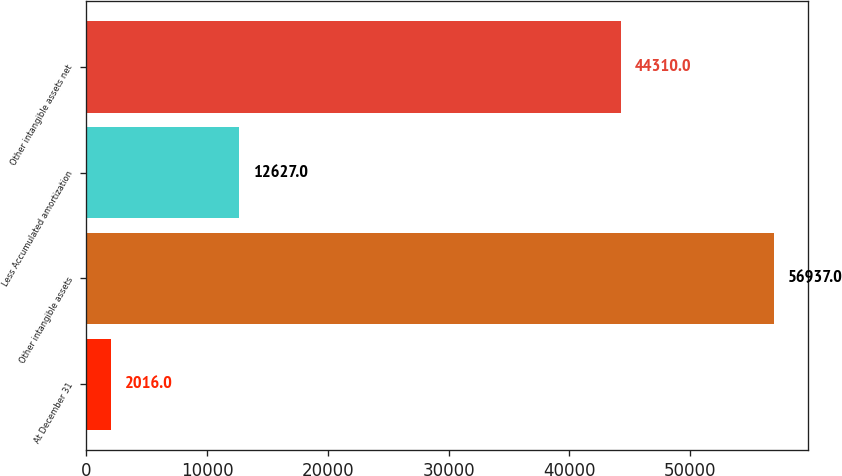Convert chart to OTSL. <chart><loc_0><loc_0><loc_500><loc_500><bar_chart><fcel>At December 31<fcel>Other intangible assets<fcel>Less Accumulated amortization<fcel>Other intangible assets net<nl><fcel>2016<fcel>56937<fcel>12627<fcel>44310<nl></chart> 